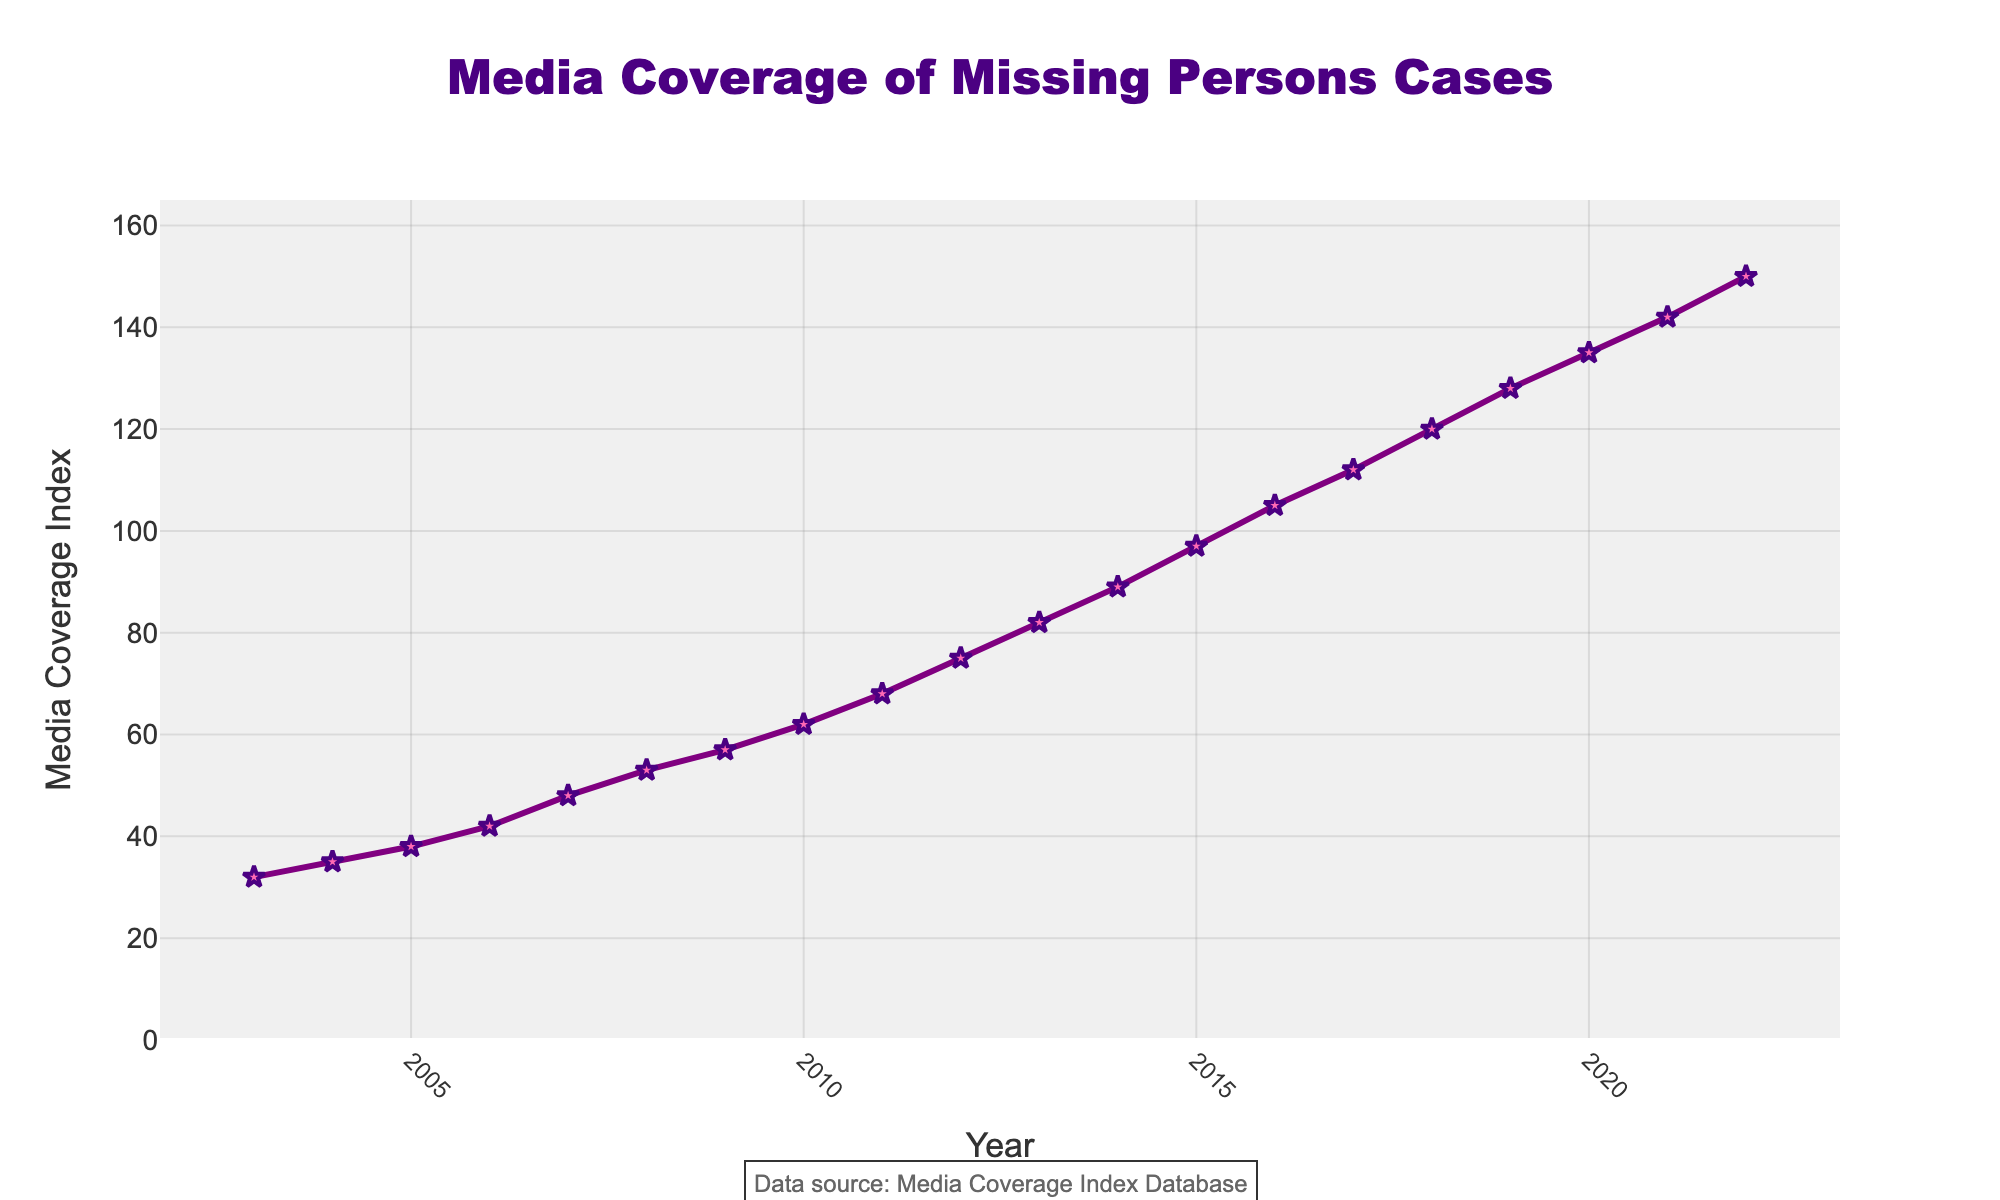What is the trend of media coverage on missing persons cases over the last two decades? The trend can be observed by looking at the line connecting the data points from 2003 to 2022. The line shows an upward trajectory which indicates that the media coverage index has increased over the years.
Answer: Increasing How much did the media coverage index increase between 2003 and 2012? To find the increase, subtract the media coverage index in 2003 from the index in 2012. The index in 2003 is 32, and in 2012 it is 75. So, 75 - 32 = 43.
Answer: 43 What was the highest media coverage index recorded, and in which year did it occur? The highest value on the y-axis is 150, which corresponds to the year 2022.
Answer: 150, 2022 Between which consecutive years was the largest jump in media coverage, and what was the magnitude of this increase? To find the largest increase, look at the differences between consecutive year's indices. The largest difference is between 2015 and 2016, where the index changes from 97 to 105, an increase of 8.
Answer: 2015-2016, 8 What was the average media coverage index over the two decades? To find the average, sum up all the media coverage index values from 2003 to 2022 and then divide by the number of years (20). The total sum is 1740, so the average is 1740 / 20 = 87.
Answer: 87 